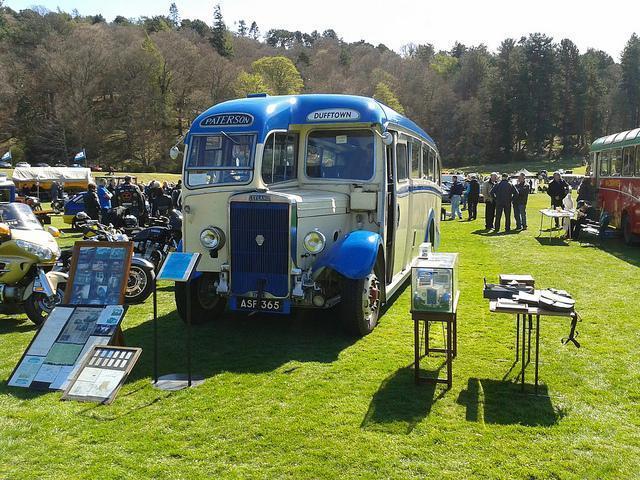How many buses are there?
Give a very brief answer. 2. 